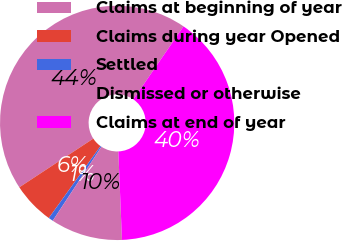Convert chart. <chart><loc_0><loc_0><loc_500><loc_500><pie_chart><fcel>Claims at beginning of year<fcel>Claims during year Opened<fcel>Settled<fcel>Dismissed or otherwise<fcel>Claims at end of year<nl><fcel>43.85%<fcel>5.82%<fcel>0.65%<fcel>9.92%<fcel>39.76%<nl></chart> 